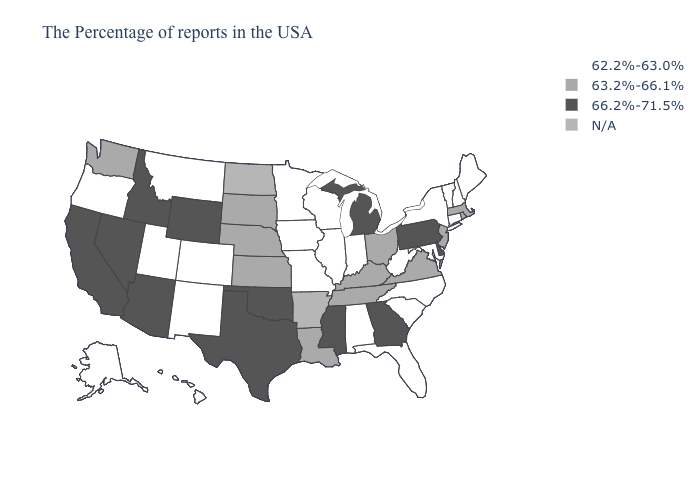What is the value of Wisconsin?
Write a very short answer. 62.2%-63.0%. What is the value of Mississippi?
Give a very brief answer. 66.2%-71.5%. Name the states that have a value in the range 63.2%-66.1%?
Give a very brief answer. Massachusetts, Rhode Island, New Jersey, Virginia, Ohio, Kentucky, Tennessee, Louisiana, Kansas, Nebraska, South Dakota, Washington. Which states have the highest value in the USA?
Answer briefly. Delaware, Pennsylvania, Georgia, Michigan, Mississippi, Oklahoma, Texas, Wyoming, Arizona, Idaho, Nevada, California. Name the states that have a value in the range 63.2%-66.1%?
Be succinct. Massachusetts, Rhode Island, New Jersey, Virginia, Ohio, Kentucky, Tennessee, Louisiana, Kansas, Nebraska, South Dakota, Washington. What is the value of Maryland?
Concise answer only. 62.2%-63.0%. Name the states that have a value in the range N/A?
Write a very short answer. Arkansas, North Dakota. What is the highest value in the USA?
Answer briefly. 66.2%-71.5%. What is the highest value in the West ?
Write a very short answer. 66.2%-71.5%. Name the states that have a value in the range 62.2%-63.0%?
Be succinct. Maine, New Hampshire, Vermont, Connecticut, New York, Maryland, North Carolina, South Carolina, West Virginia, Florida, Indiana, Alabama, Wisconsin, Illinois, Missouri, Minnesota, Iowa, Colorado, New Mexico, Utah, Montana, Oregon, Alaska, Hawaii. What is the value of New Mexico?
Give a very brief answer. 62.2%-63.0%. Name the states that have a value in the range 62.2%-63.0%?
Give a very brief answer. Maine, New Hampshire, Vermont, Connecticut, New York, Maryland, North Carolina, South Carolina, West Virginia, Florida, Indiana, Alabama, Wisconsin, Illinois, Missouri, Minnesota, Iowa, Colorado, New Mexico, Utah, Montana, Oregon, Alaska, Hawaii. 